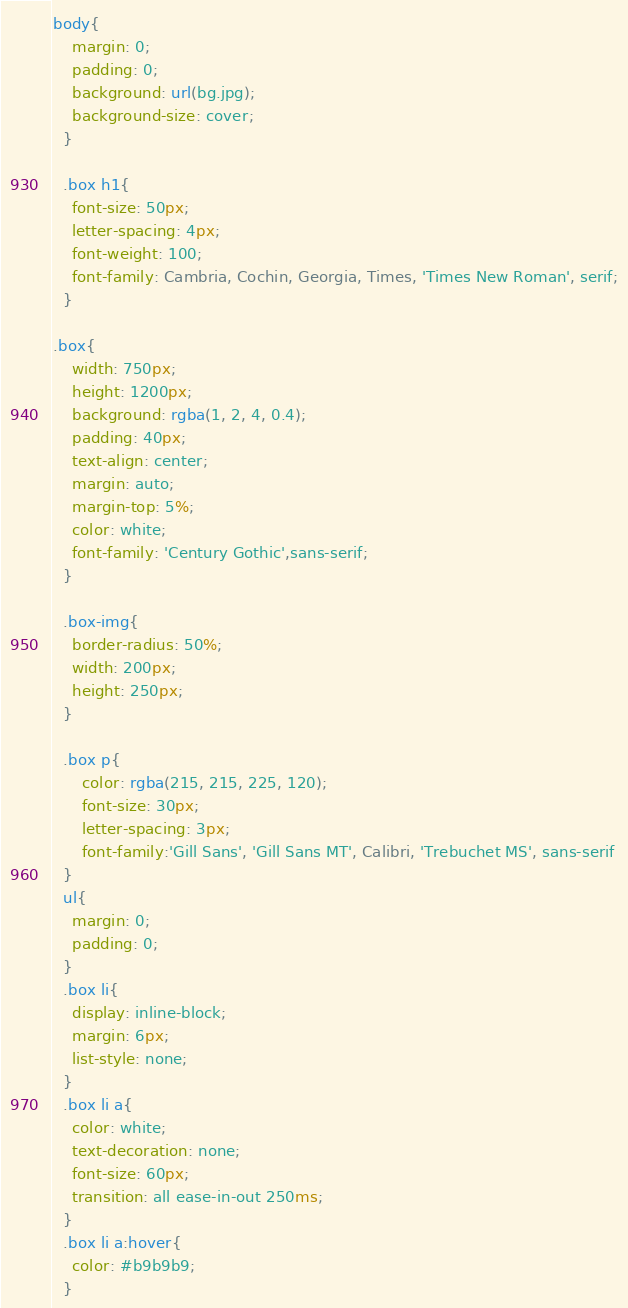Convert code to text. <code><loc_0><loc_0><loc_500><loc_500><_CSS_>body{
    margin: 0;
    padding: 0;
    background: url(bg.jpg);
    background-size: cover;
  }

  .box h1{
    font-size: 50px;
    letter-spacing: 4px;
    font-weight: 100;
    font-family: Cambria, Cochin, Georgia, Times, 'Times New Roman', serif;
  }

.box{
    width: 750px;
    height: 1200px;
    background: rgba(1, 2, 4, 0.4);
    padding: 40px;
    text-align: center;
    margin: auto;
    margin-top: 5%;
    color: white;
    font-family: 'Century Gothic',sans-serif;
  }

  .box-img{
    border-radius: 50%;
    width: 200px;
    height: 250px;
  }

  .box p{
      color: rgba(215, 215, 225, 120);
      font-size: 30px;
      letter-spacing: 3px;
      font-family:'Gill Sans', 'Gill Sans MT', Calibri, 'Trebuchet MS', sans-serif
  }
  ul{
    margin: 0;
    padding: 0;
  }
  .box li{
    display: inline-block;
    margin: 6px;
    list-style: none;
  }
  .box li a{
    color: white;
    text-decoration: none;
    font-size: 60px;
    transition: all ease-in-out 250ms;
  }
  .box li a:hover{
    color: #b9b9b9;
  }
</code> 